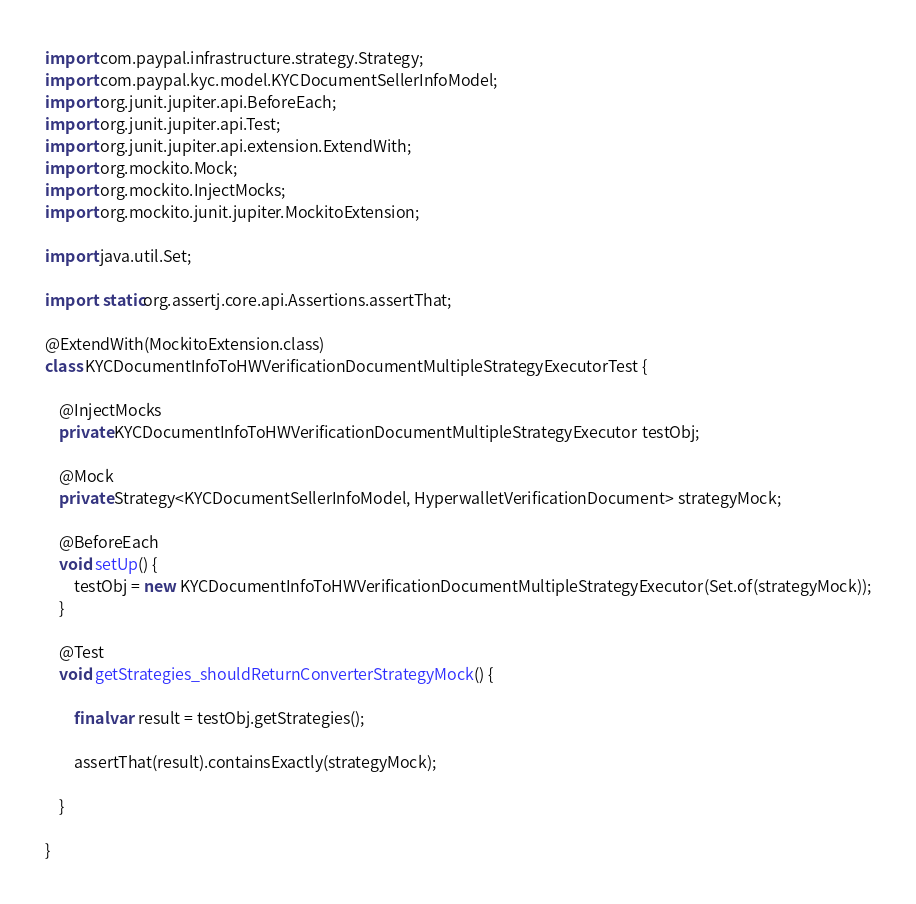Convert code to text. <code><loc_0><loc_0><loc_500><loc_500><_Java_>import com.paypal.infrastructure.strategy.Strategy;
import com.paypal.kyc.model.KYCDocumentSellerInfoModel;
import org.junit.jupiter.api.BeforeEach;
import org.junit.jupiter.api.Test;
import org.junit.jupiter.api.extension.ExtendWith;
import org.mockito.Mock;
import org.mockito.InjectMocks;
import org.mockito.junit.jupiter.MockitoExtension;

import java.util.Set;

import static org.assertj.core.api.Assertions.assertThat;

@ExtendWith(MockitoExtension.class)
class KYCDocumentInfoToHWVerificationDocumentMultipleStrategyExecutorTest {

	@InjectMocks
	private KYCDocumentInfoToHWVerificationDocumentMultipleStrategyExecutor testObj;

	@Mock
	private Strategy<KYCDocumentSellerInfoModel, HyperwalletVerificationDocument> strategyMock;

	@BeforeEach
	void setUp() {
		testObj = new KYCDocumentInfoToHWVerificationDocumentMultipleStrategyExecutor(Set.of(strategyMock));
	}

	@Test
	void getStrategies_shouldReturnConverterStrategyMock() {

		final var result = testObj.getStrategies();

		assertThat(result).containsExactly(strategyMock);

	}

}
</code> 